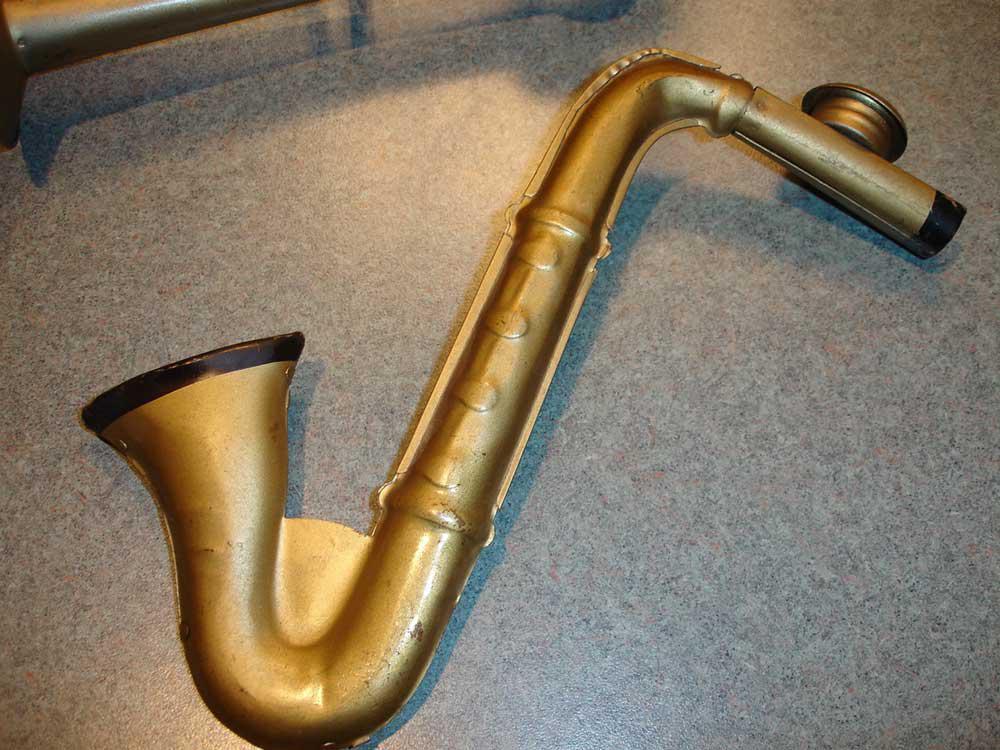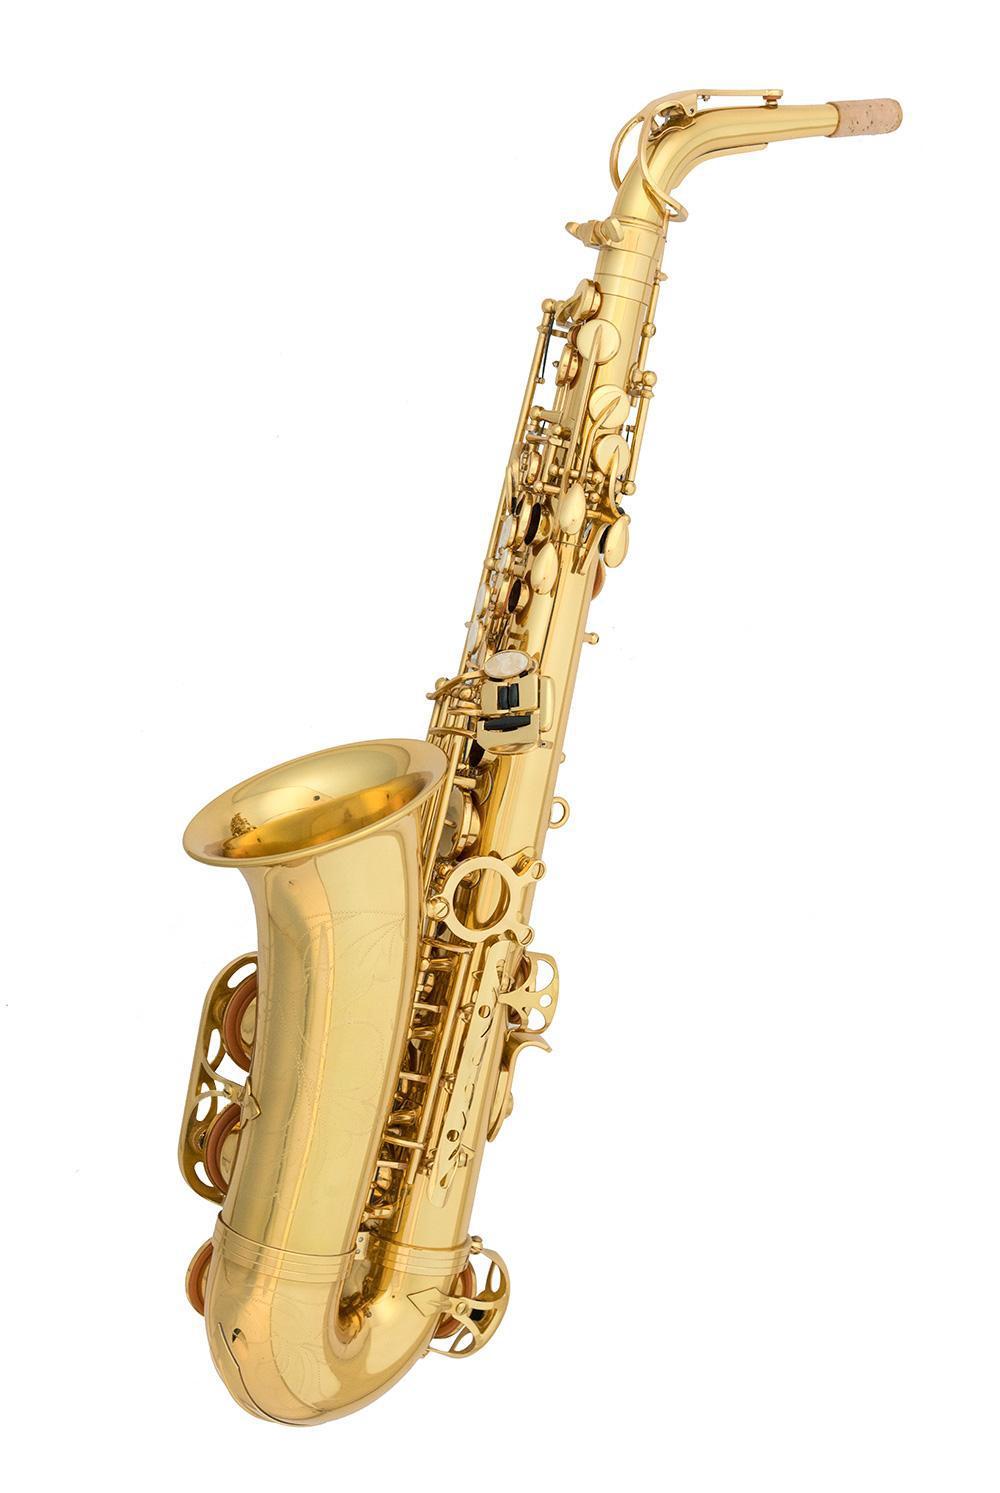The first image is the image on the left, the second image is the image on the right. Assess this claim about the two images: "One image shows a saxophone on a plain black background.". Correct or not? Answer yes or no. No. The first image is the image on the left, the second image is the image on the right. Examine the images to the left and right. Is the description "An image shows a brass colored instrument with an imperfect finish on a black background." accurate? Answer yes or no. No. 